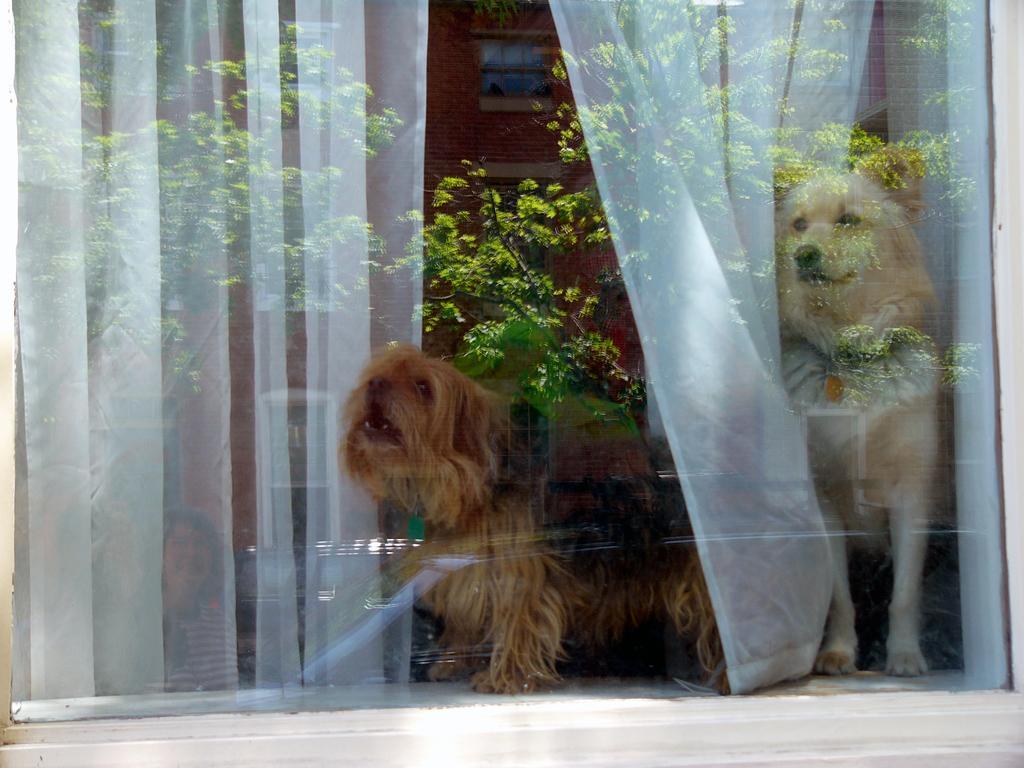Can you describe this image briefly? In this image we can see one glass window, two dogs in the window, some white curtains in the window and one woman sitting. In the window glass we can see the reflections of trees, one building and some objects on the ground. 